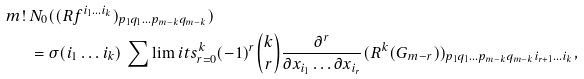<formula> <loc_0><loc_0><loc_500><loc_500>m ! \, & N _ { 0 } ( ( R f ^ { i _ { 1 } \dots i _ { k } } ) _ { p _ { 1 } q _ { 1 } \dots p _ { m - k } q _ { m - k } } ) \\ & = \sigma ( i _ { 1 } \dots i _ { k } ) \, \sum \lim i t s _ { r = 0 } ^ { k } ( - 1 ) ^ { r } \binom { k } { r } \frac { \partial ^ { r } } { \partial x _ { i _ { 1 } } \dots \partial x _ { i _ { r } } } ( R ^ { k } ( G _ { m - r } ) ) _ { p _ { 1 } q _ { 1 } \dots p _ { m - k } q _ { m - k } i _ { r + 1 } \dots i _ { k } } ,</formula> 